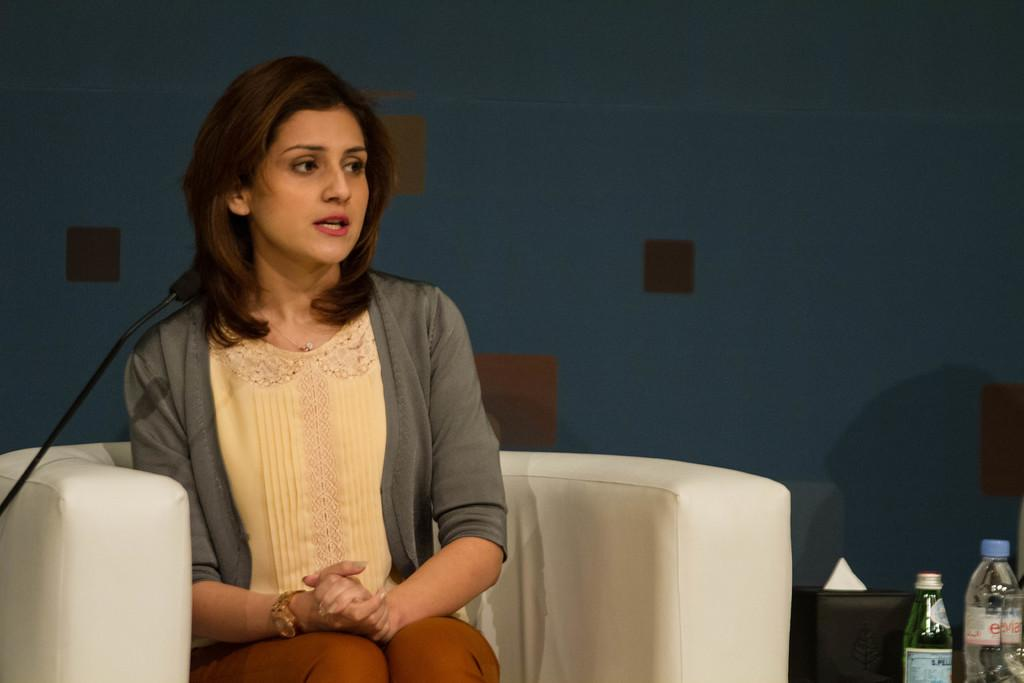What is the woman doing in the image? The woman is sitting on a couch in the image. What object is in front of the woman? There is a microphone in front of the woman. What else can be seen in front of the woman? There are bottles in front of the woman. Can you describe the background of the image? The background of the image has blue and brown colors. What type of toys can be seen in the image? There are no toys present in the image. Is there an argument happening between the woman and someone else in the image? There is no indication of an argument in the image; the woman is simply sitting on a couch with a microphone and bottles in front of her. 